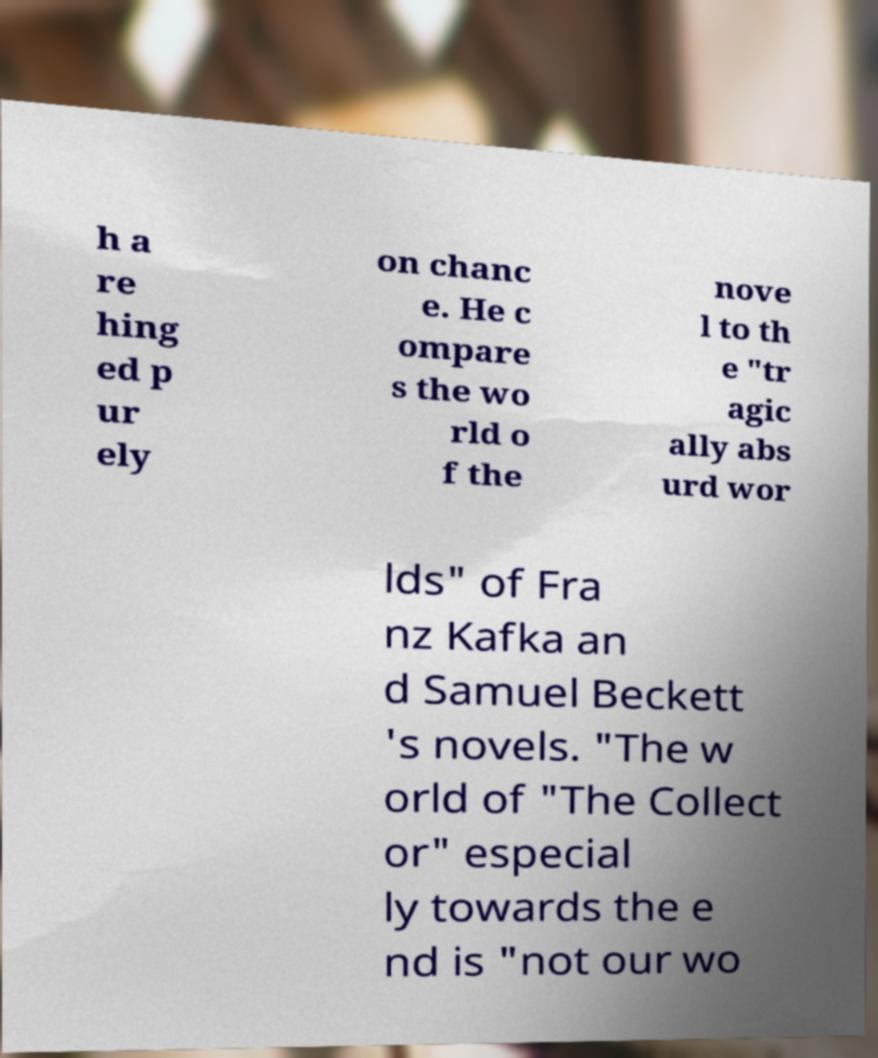Can you read and provide the text displayed in the image?This photo seems to have some interesting text. Can you extract and type it out for me? h a re hing ed p ur ely on chanc e. He c ompare s the wo rld o f the nove l to th e "tr agic ally abs urd wor lds" of Fra nz Kafka an d Samuel Beckett 's novels. "The w orld of "The Collect or" especial ly towards the e nd is "not our wo 